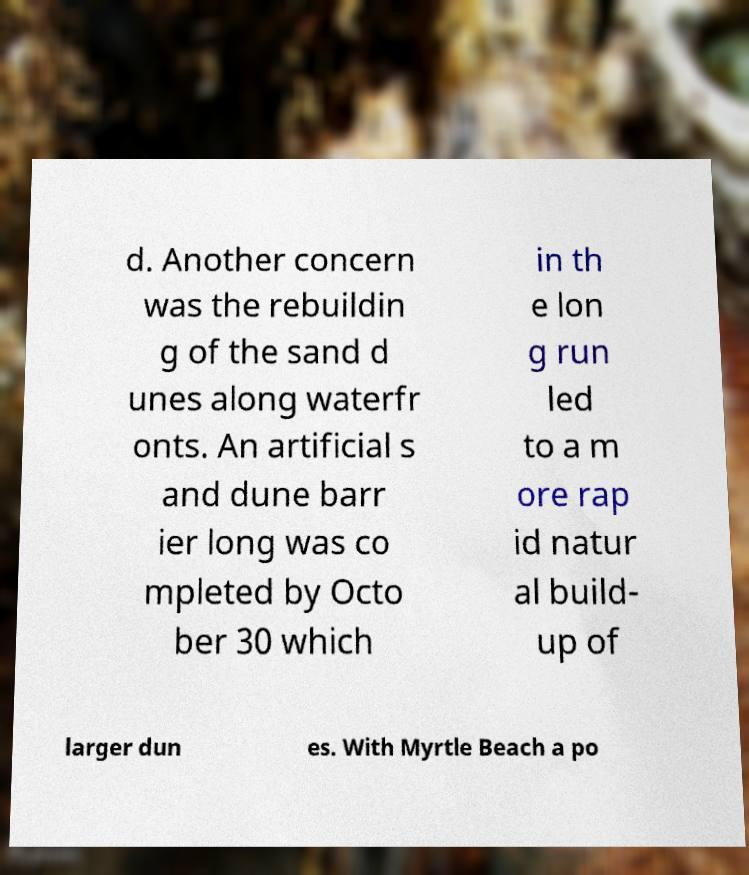For documentation purposes, I need the text within this image transcribed. Could you provide that? d. Another concern was the rebuildin g of the sand d unes along waterfr onts. An artificial s and dune barr ier long was co mpleted by Octo ber 30 which in th e lon g run led to a m ore rap id natur al build- up of larger dun es. With Myrtle Beach a po 